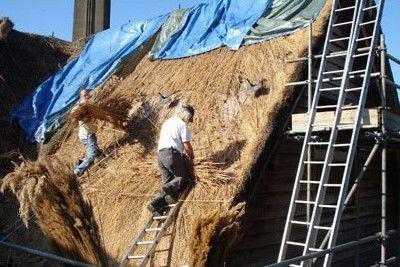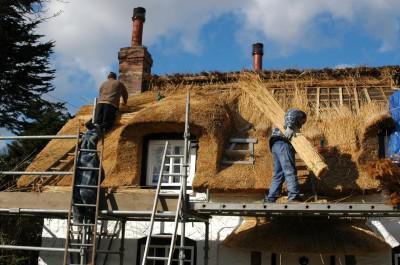The first image is the image on the left, the second image is the image on the right. For the images shown, is this caption "A single man is working on the roof of the house in the image on the right." true? Answer yes or no. No. The first image is the image on the left, the second image is the image on the right. Evaluate the accuracy of this statement regarding the images: "The right image shows exactly one man on some type of platform in front of a sloped unfinished roof with at least one bundle of thatch propped on it and no chimney.". Is it true? Answer yes or no. No. 